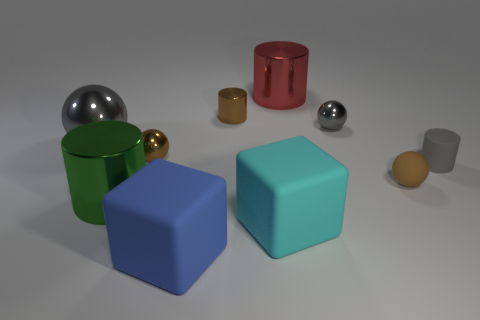Subtract all matte cylinders. How many cylinders are left? 3 Subtract all green cubes. How many gray balls are left? 2 Subtract 1 cylinders. How many cylinders are left? 3 Subtract all green cylinders. How many cylinders are left? 3 Subtract all blocks. How many objects are left? 8 Subtract all red cylinders. Subtract all gray blocks. How many cylinders are left? 3 Add 3 red metallic things. How many red metallic things are left? 4 Add 4 brown objects. How many brown objects exist? 7 Subtract 0 gray blocks. How many objects are left? 10 Subtract all brown metallic cylinders. Subtract all tiny brown cylinders. How many objects are left? 8 